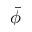<formula> <loc_0><loc_0><loc_500><loc_500>\bar { \phi }</formula> 